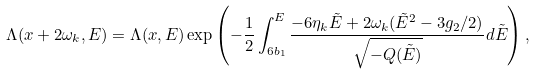Convert formula to latex. <formula><loc_0><loc_0><loc_500><loc_500>\Lambda ( x + 2 \omega _ { k } , E ) = \Lambda ( x , E ) \exp \left ( - \frac { 1 } { 2 } \int _ { 6 b _ { 1 } } ^ { E } \frac { - 6 \eta _ { k } \tilde { E } + 2 \omega _ { k } ( \tilde { E } ^ { 2 } - 3 g _ { 2 } / 2 ) } { \sqrt { - Q ( \tilde { E } ) } } d \tilde { E } \right ) ,</formula> 